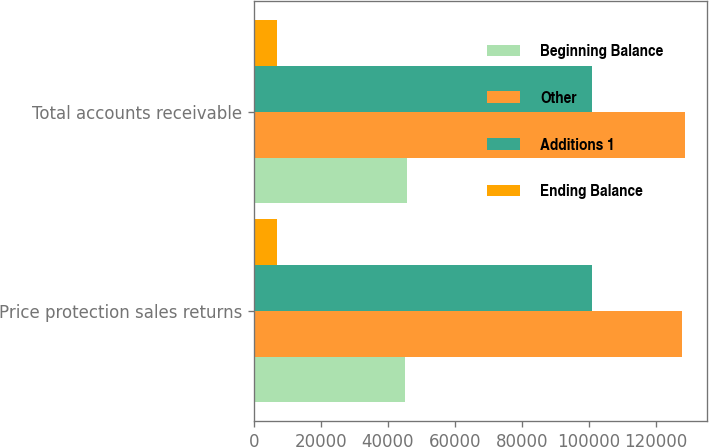Convert chart. <chart><loc_0><loc_0><loc_500><loc_500><stacked_bar_chart><ecel><fcel>Price protection sales returns<fcel>Total accounts receivable<nl><fcel>Beginning Balance<fcel>45153<fcel>45552<nl><fcel>Other<fcel>127744<fcel>128718<nl><fcel>Additions 1<fcel>100934<fcel>100938<nl><fcel>Ending Balance<fcel>6849<fcel>6849<nl></chart> 